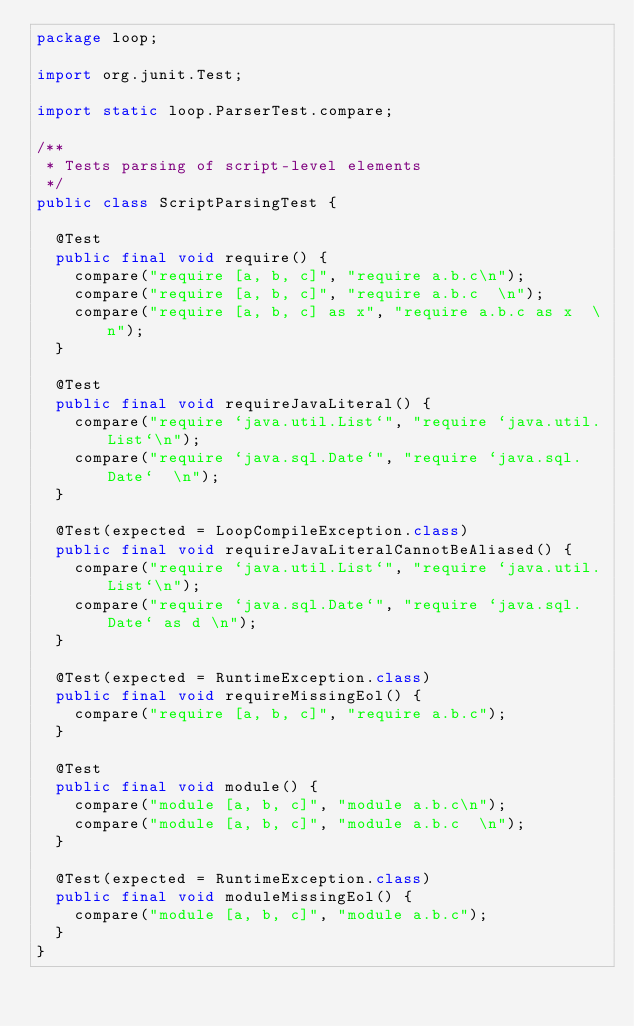Convert code to text. <code><loc_0><loc_0><loc_500><loc_500><_Java_>package loop;

import org.junit.Test;

import static loop.ParserTest.compare;

/**
 * Tests parsing of script-level elements
 */
public class ScriptParsingTest {

  @Test
  public final void require() {
    compare("require [a, b, c]", "require a.b.c\n");
    compare("require [a, b, c]", "require a.b.c  \n");
    compare("require [a, b, c] as x", "require a.b.c as x  \n");
  }

  @Test
  public final void requireJavaLiteral() {
    compare("require `java.util.List`", "require `java.util.List`\n");
    compare("require `java.sql.Date`", "require `java.sql.Date`  \n");
  }

  @Test(expected = LoopCompileException.class)
  public final void requireJavaLiteralCannotBeAliased() {
    compare("require `java.util.List`", "require `java.util.List`\n");
    compare("require `java.sql.Date`", "require `java.sql.Date` as d \n");
  }

  @Test(expected = RuntimeException.class)
  public final void requireMissingEol() {
    compare("require [a, b, c]", "require a.b.c");
  }

  @Test
  public final void module() {
    compare("module [a, b, c]", "module a.b.c\n");
    compare("module [a, b, c]", "module a.b.c  \n");
  }

  @Test(expected = RuntimeException.class)
  public final void moduleMissingEol() {
    compare("module [a, b, c]", "module a.b.c");
  }
}
</code> 